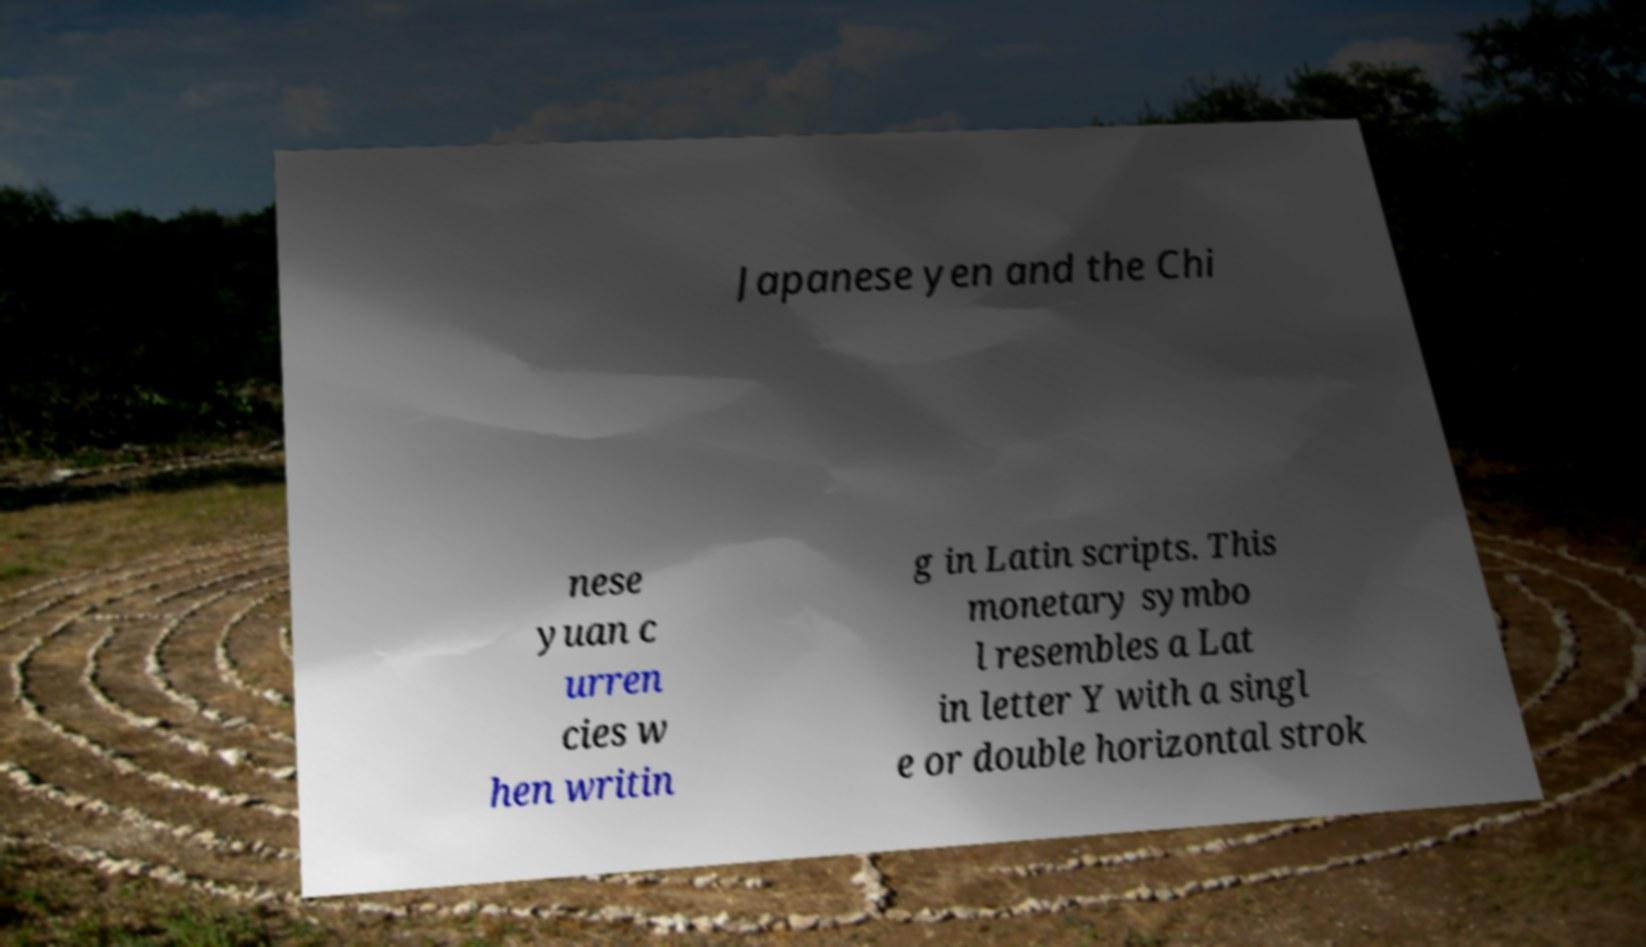Please read and relay the text visible in this image. What does it say? Japanese yen and the Chi nese yuan c urren cies w hen writin g in Latin scripts. This monetary symbo l resembles a Lat in letter Y with a singl e or double horizontal strok 